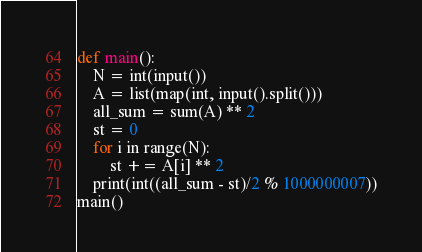<code> <loc_0><loc_0><loc_500><loc_500><_Python_>def main():
    N = int(input())
    A = list(map(int, input().split()))
    all_sum = sum(A) ** 2
    st = 0
    for i in range(N):
        st += A[i] ** 2
    print(int((all_sum - st)/2 % 1000000007))
main()
</code> 